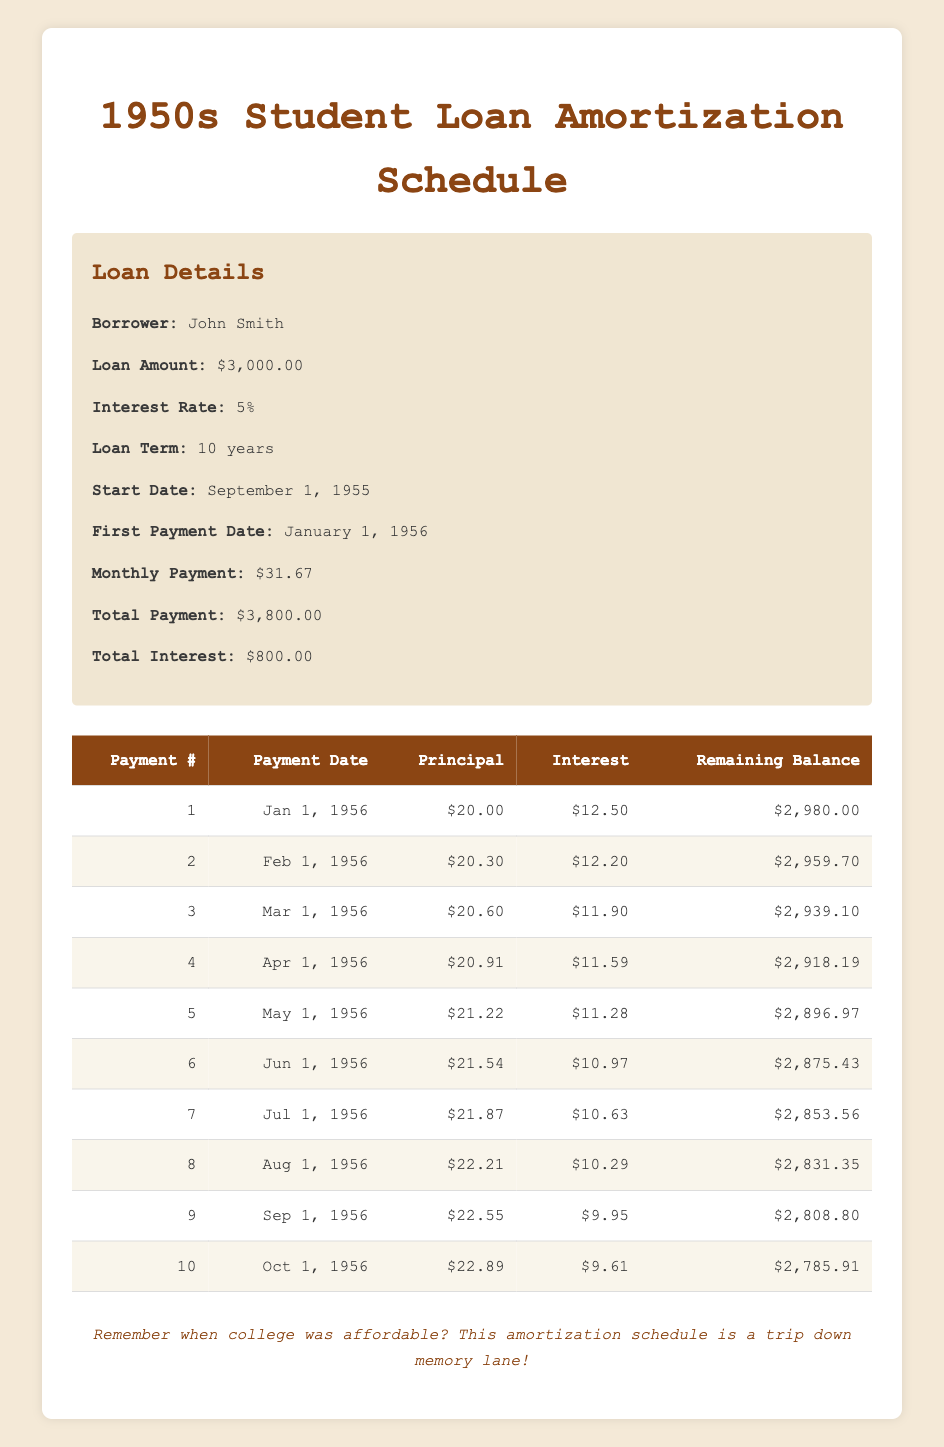What is the total amount John Smith will pay over the life of the loan? The total payment is explicitly provided in the loan details. It states that the total payment John Smith will make is $3,800.00.
Answer: 3800 What is the monthly payment amount? The monthly payment amount is listed in the loan details, which states it is $31.67.
Answer: 31.67 How much interest will John Smith pay in the first payment? The interest payment for the first payment is specified in the amortization schedule. It states that the interest payment is $12.50.
Answer: 12.50 What is the remaining balance after the second payment? The second payment shows a remaining balance of $2,959.70. This can be found directly in the amortization schedule.
Answer: 2959.70 What is the total principal paid after the first four payments? To find the total principal paid after the first four payments, we sum the principal payments for the first four entries: 20.00 + 20.30 + 20.60 + 20.91 = 81.81.
Answer: 81.81 Is the monthly payment of $31.67 higher than the average principal payment in the first 10 payments? First, we need to calculate the total principal paid in the first 10 payments, which is the sum of all principal payments: (20.00 + 20.30 + 20.60 + 20.91 + 21.22 + 21.54 + 21.87 + 22.21 + 22.55 + 22.89) =  211.13. There are 10 payments, so the average principal payment is 211.13 / 10 = 21.11. Since $31.67 > $21.11, the answer is yes.
Answer: Yes How much interest is paid by the sixth payment? The interest payment for the sixth payment is provided in the amortization schedule. It states that the interest payment is $10.97.
Answer: 10.97 What is the total interest paid after the first five payments? We sum the interest payments for the first five payments: (12.50 + 12.20 + 11.90 + 11.59 + 11.28) = 59.47.
Answer: 59.47 What is the remaining balance after the tenth payment? The remaining balance after the tenth payment is given in the amortization schedule, which shows it is $2,785.91.
Answer: 2785.91 Was the principal payment in the third payment less than $21.00? The principal payment in the third payment is $20.60, which is less than $21.00. Therefore, the answer is yes.
Answer: Yes 